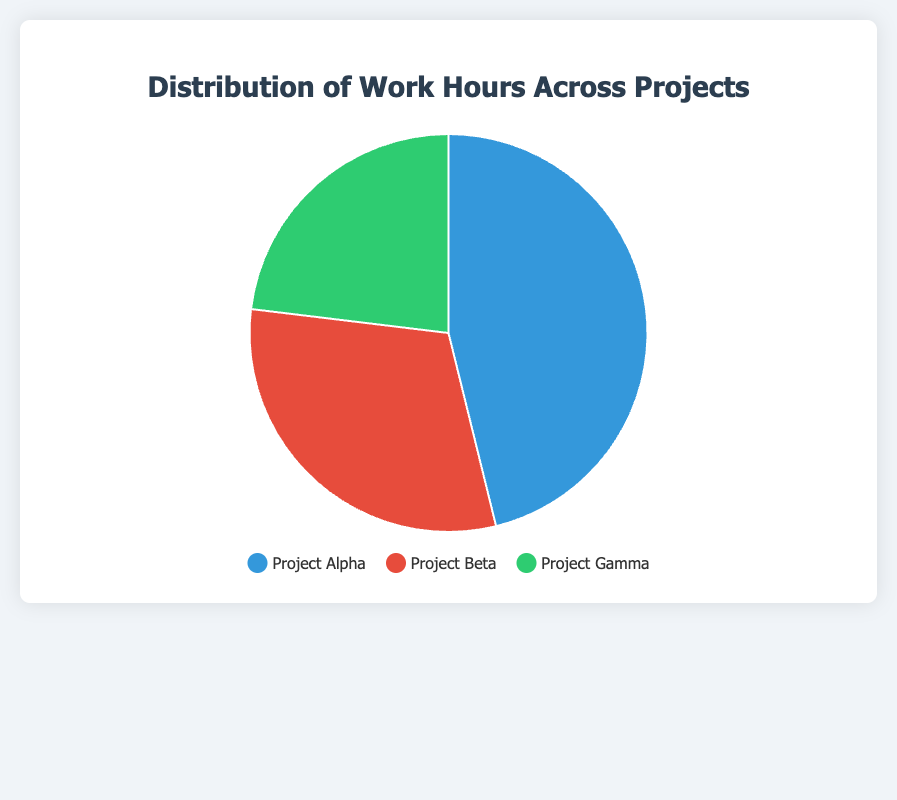What are the work hours for Project Alpha? The pie chart shows different sections labeled with project names. From the chart, locate the section for Project Alpha and see the associated work hours.
Answer: 120 hours Which project has the least work hours, and how many hours are allocated to it? Look at the pie sections for the smallest segment, which is labeled as Project Gamma, and see its work hours.
Answer: Project Gamma, 60 hours What's the total amount of work hours across all projects? Add the work hours for all three projects: Project Alpha (120), Project Beta (80), and Project Gamma (60). The total is 120 + 80 + 60.
Answer: 260 hours How does the work hours for Project Beta compare to Project Alpha? Compare the numbers directly from the chart: Project Beta has 80 hours and Project Alpha has 120 hours. Project Beta has fewer hours than Project Alpha by 120 - 80.
Answer: 40 hours less What percentage of total work hours is spent on Project Gamma? Calculate the percentage of work hours for Project Gamma out of the total. (60 / 260) * 100 = 23.08%, approximately.
Answer: ~23% If the total hours were equally distributed, how many hours would each project receive? Calculate the equal distribution by dividing the total work hours by the number of projects: 260 / 3.
Answer: Approximately 86.67 hours Which project segment appears largest in the pie chart and what could this indicate about its work hours distribution? Visually identify the largest segment in the pie chart, which is Project Alpha. This indicates that Project Alpha has the highest portion of work hours.
Answer: Project Alpha What is the combined work hours for Projects Beta and Gamma? Add the work hours for Project Beta (80) and Project Gamma (60): 80 + 60.
Answer: 140 hours Considering the current distribution, if Project Beta received an additional 20 hours, what would be its new total and how would that compare to Project Alpha? Add 20 hours to Project Beta's current 80 hours, resulting in 100 hours. Compare this to Project Alpha’s 120 hours.
Answer: 100 hours, 20 hours less 